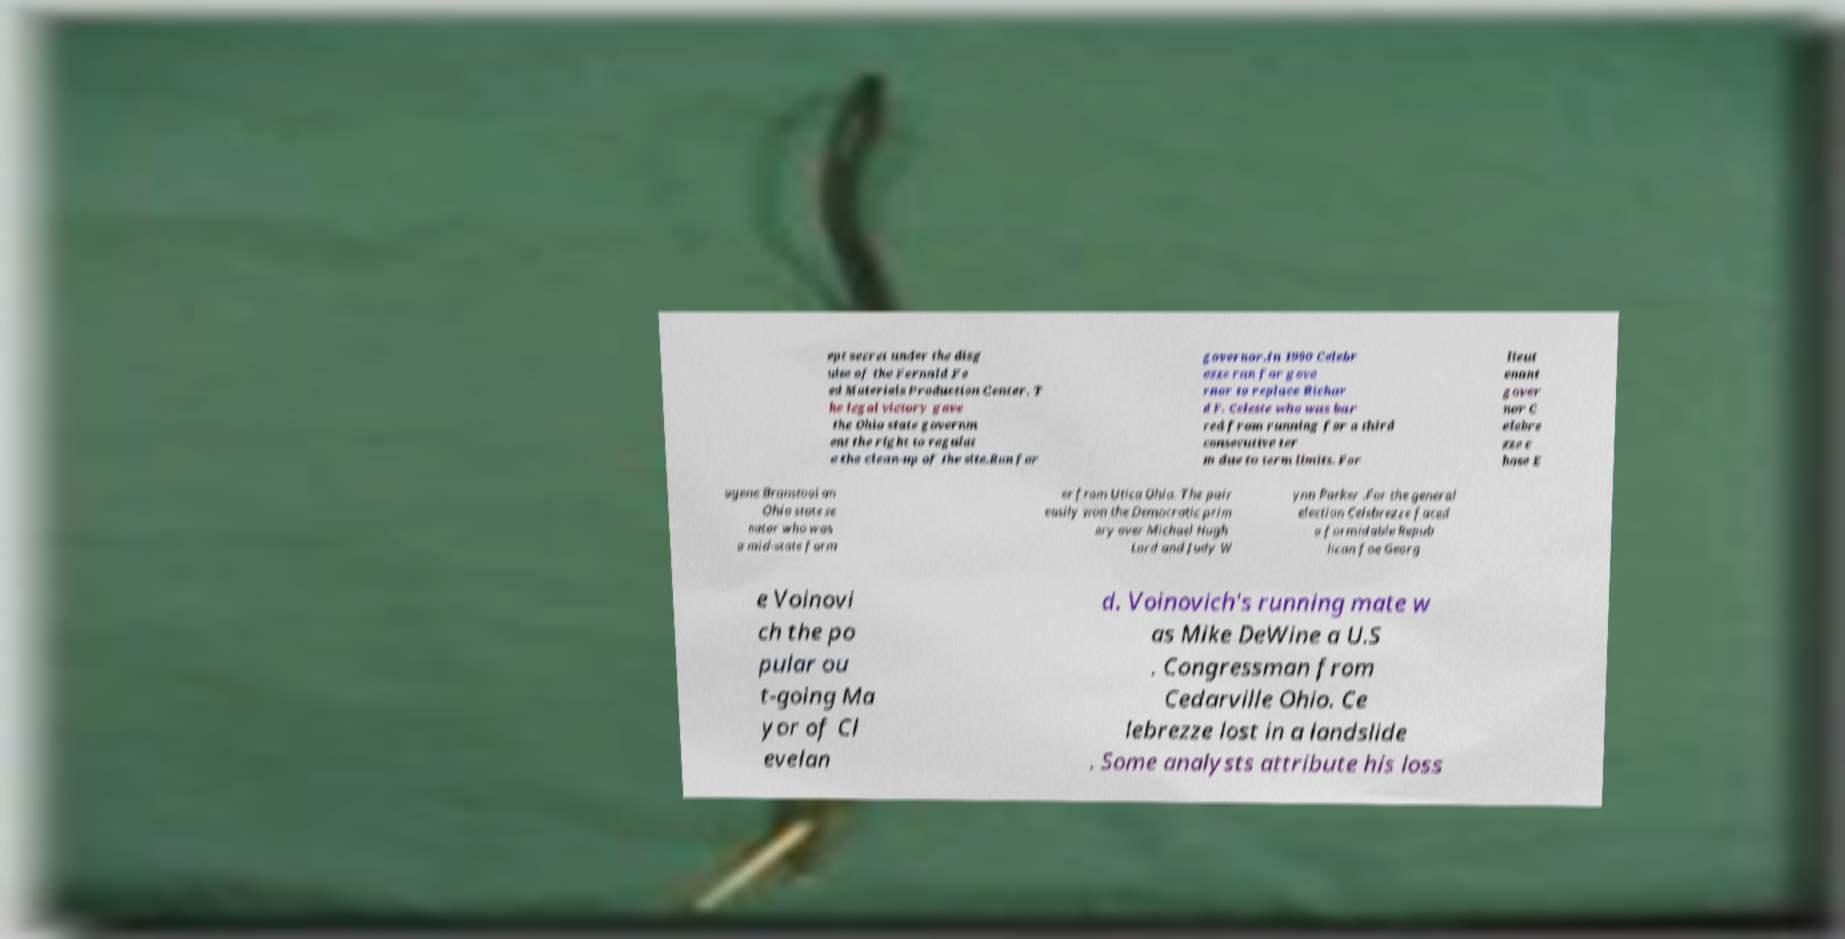Could you extract and type out the text from this image? ept secret under the disg uise of the Fernald Fe ed Materials Production Center. T he legal victory gave the Ohio state governm ent the right to regulat e the clean-up of the site.Run for governor.In 1990 Celebr ezze ran for gove rnor to replace Richar d F. Celeste who was bar red from running for a third consecutive ter m due to term limits. For lieut enant gover nor C elebre zze c hose E ugene Branstool an Ohio state se nator who was a mid-state farm er from Utica Ohio. The pair easily won the Democratic prim ary over Michael Hugh Lord and Judy W ynn Parker .For the general election Celebrezze faced a formidable Repub lican foe Georg e Voinovi ch the po pular ou t-going Ma yor of Cl evelan d. Voinovich's running mate w as Mike DeWine a U.S . Congressman from Cedarville Ohio. Ce lebrezze lost in a landslide . Some analysts attribute his loss 